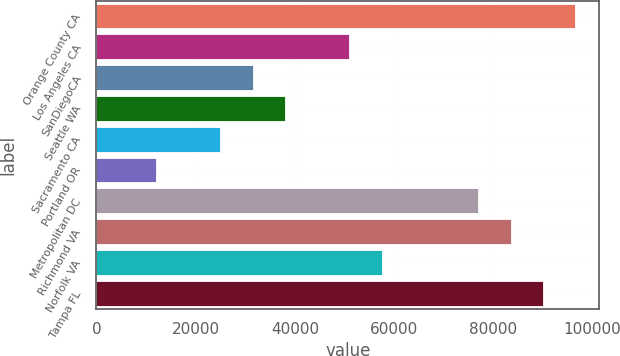<chart> <loc_0><loc_0><loc_500><loc_500><bar_chart><fcel>Orange County CA<fcel>Los Angeles CA<fcel>SanDiegoCA<fcel>Seattle WA<fcel>Sacramento CA<fcel>Portland OR<fcel>Metropolitan DC<fcel>Richmond VA<fcel>Norfolk VA<fcel>Tampa FL<nl><fcel>96509.2<fcel>50985.4<fcel>31475.2<fcel>37978.6<fcel>24971.8<fcel>11965<fcel>76999<fcel>83502.4<fcel>57488.8<fcel>90005.8<nl></chart> 